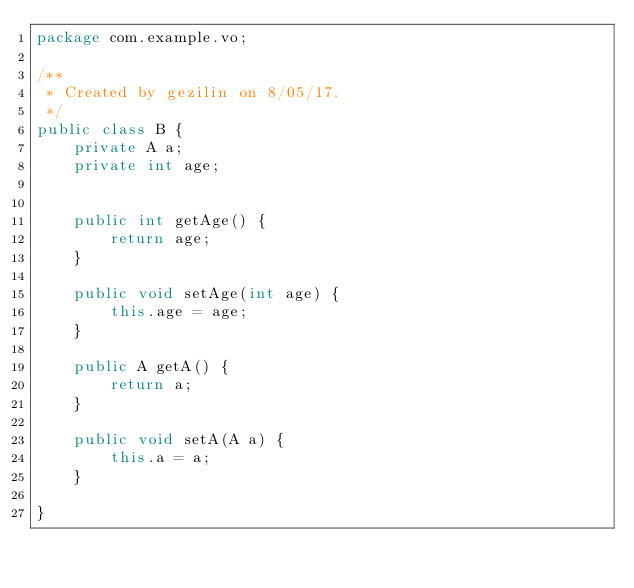Convert code to text. <code><loc_0><loc_0><loc_500><loc_500><_Java_>package com.example.vo;

/**
 * Created by gezilin on 8/05/17.
 */
public class B {
    private A a;
    private int age;


    public int getAge() {
        return age;
    }

    public void setAge(int age) {
        this.age = age;
    }

    public A getA() {
        return a;
    }

    public void setA(A a) {
        this.a = a;
    }

}
</code> 